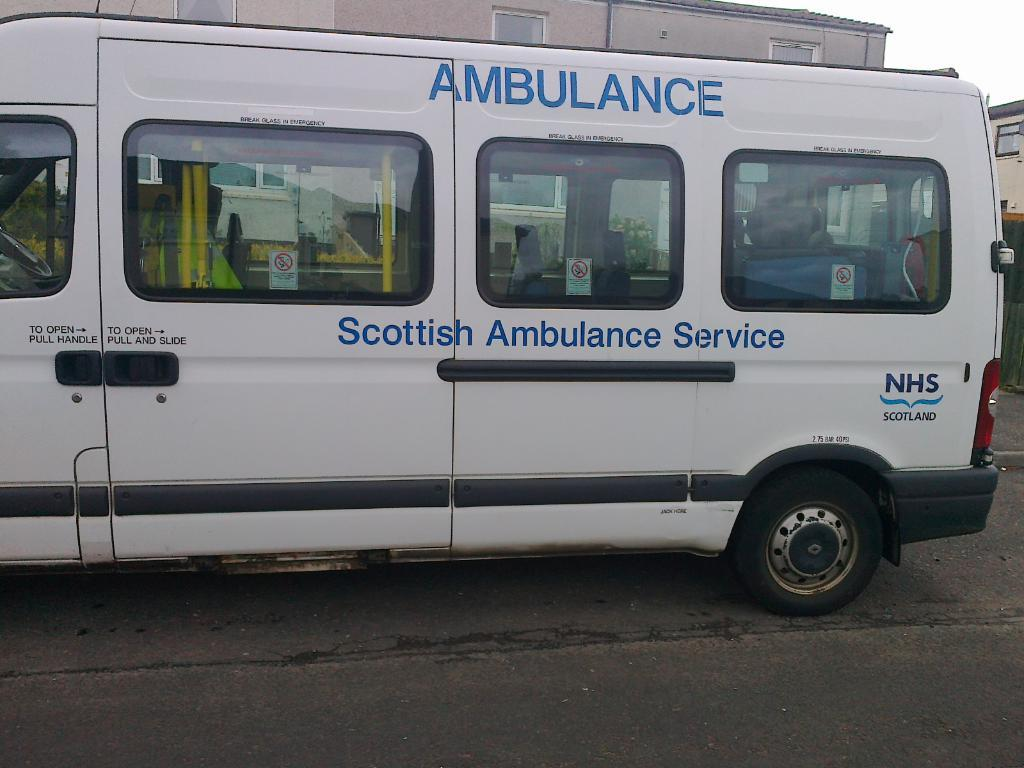Provide a one-sentence caption for the provided image. A white ambulance from the Scottish Ambulance Service. 